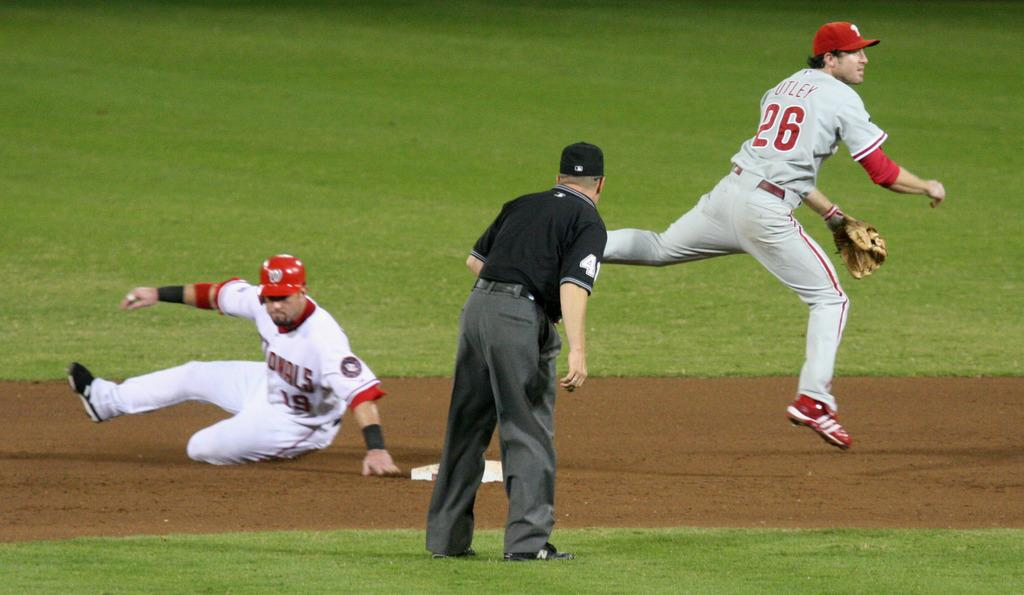<image>
Share a concise interpretation of the image provided. Player 26 has just thrown the ball while another player slides at the base. 